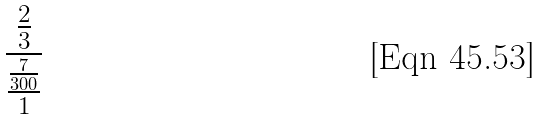<formula> <loc_0><loc_0><loc_500><loc_500>\frac { \frac { 2 } { 3 } } { \frac { \frac { 7 } { 3 0 0 } } { 1 } }</formula> 